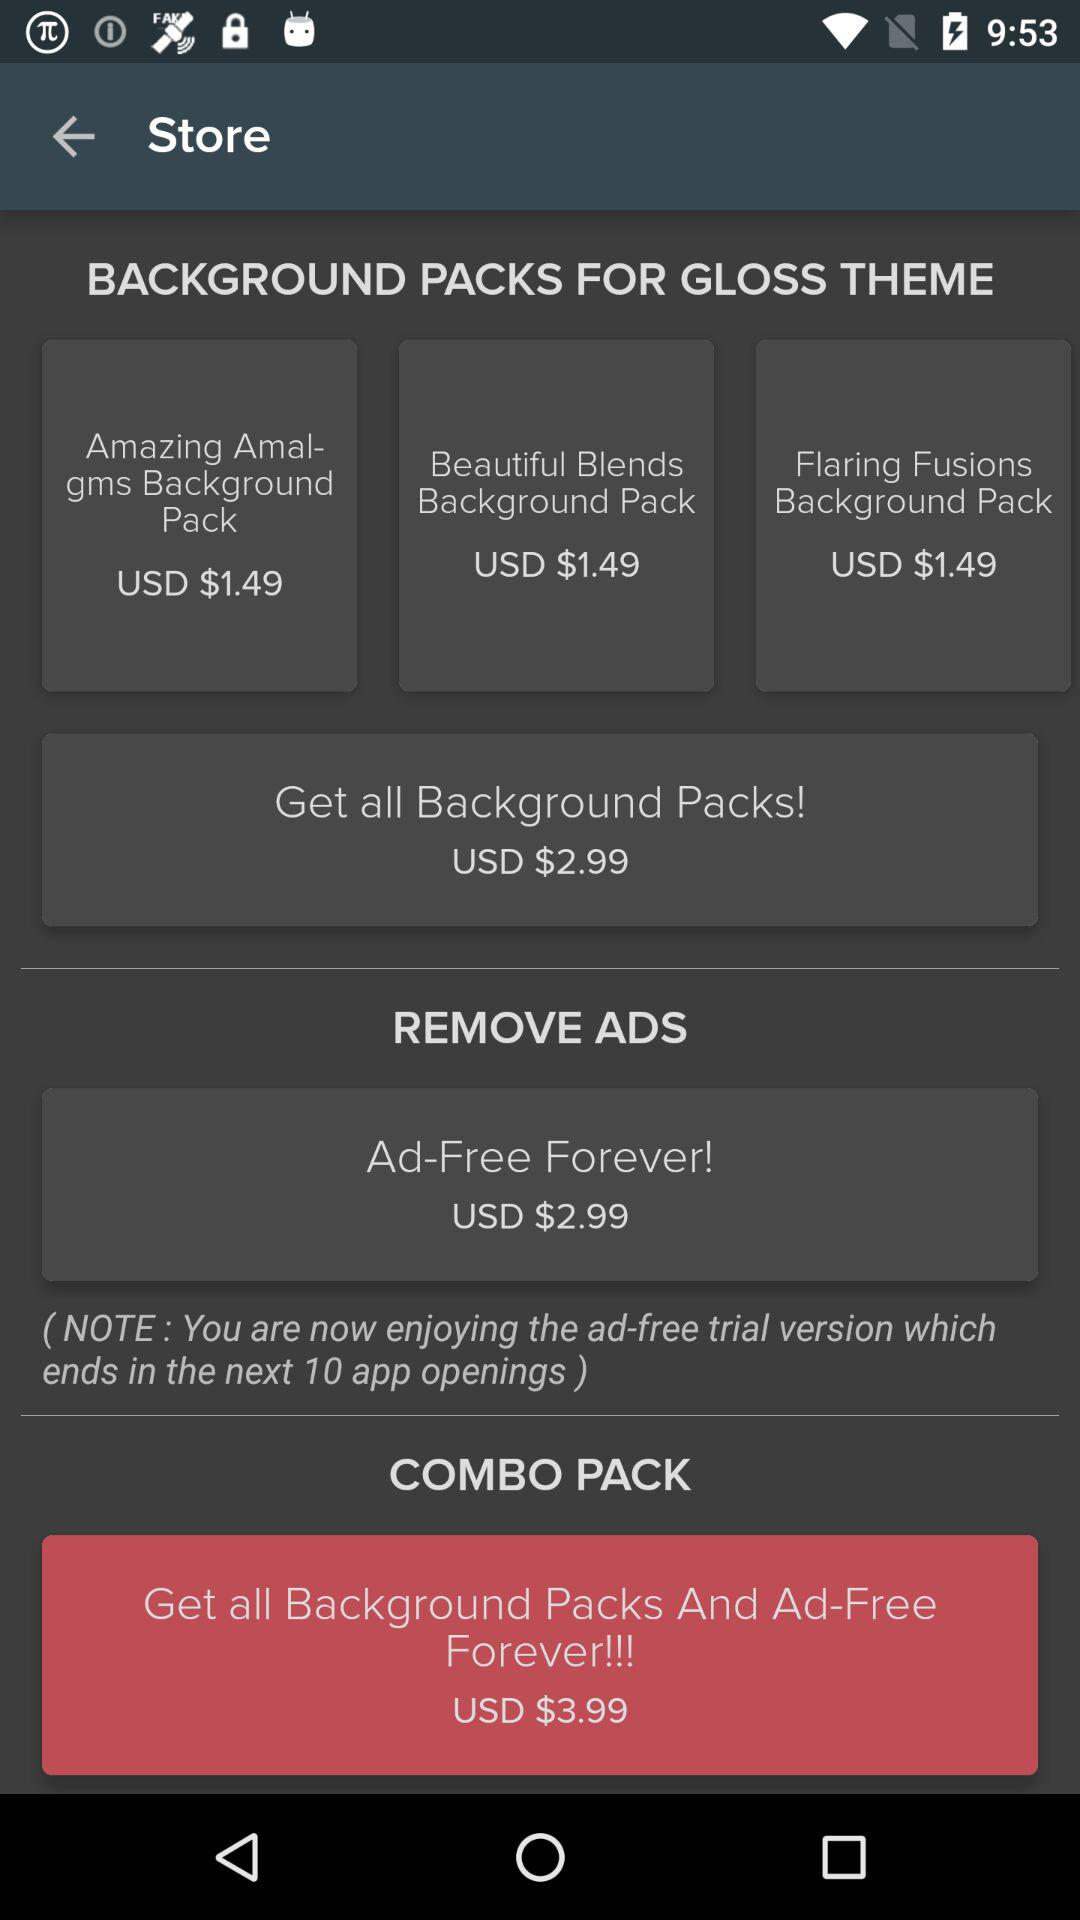How many background packs are available for purchase?
Answer the question using a single word or phrase. 3 